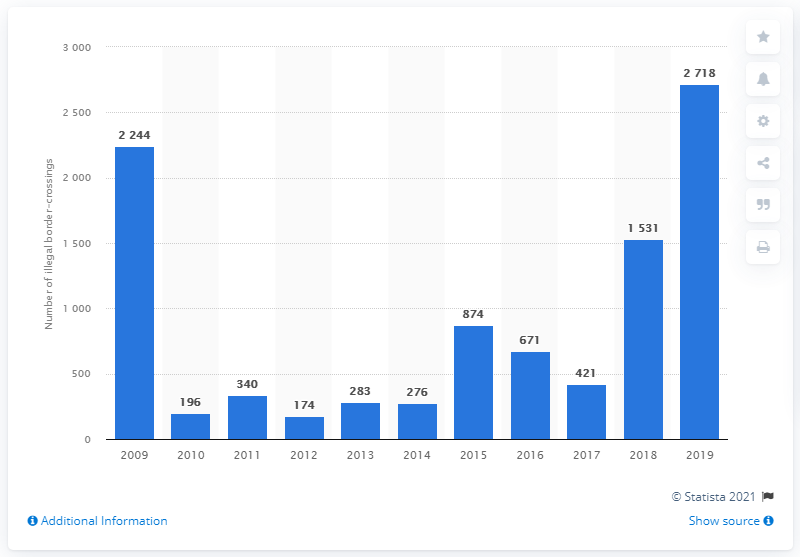Identify some key points in this picture. In 2019, a total of 2,718 illegal immigrants entered the European Union through the Canary Islands. 